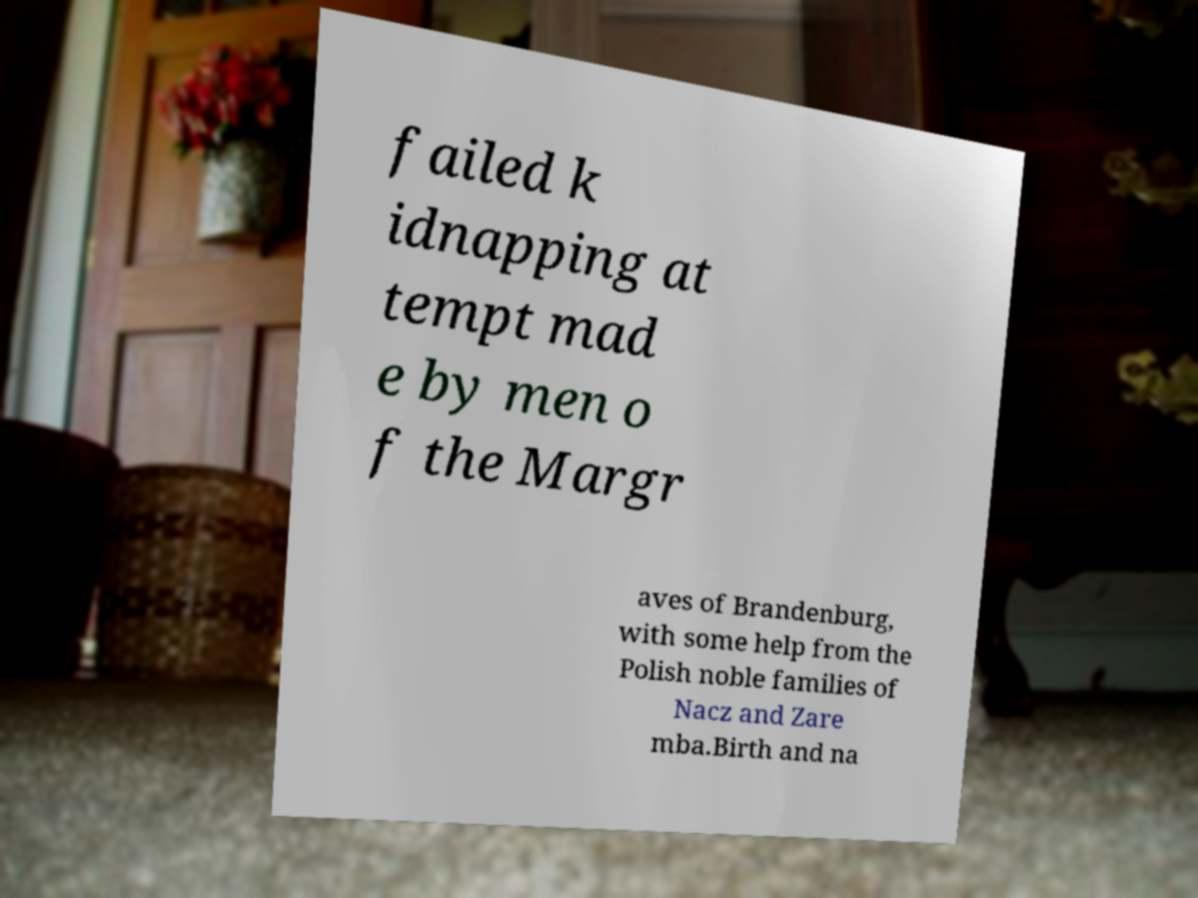Please identify and transcribe the text found in this image. failed k idnapping at tempt mad e by men o f the Margr aves of Brandenburg, with some help from the Polish noble families of Nacz and Zare mba.Birth and na 